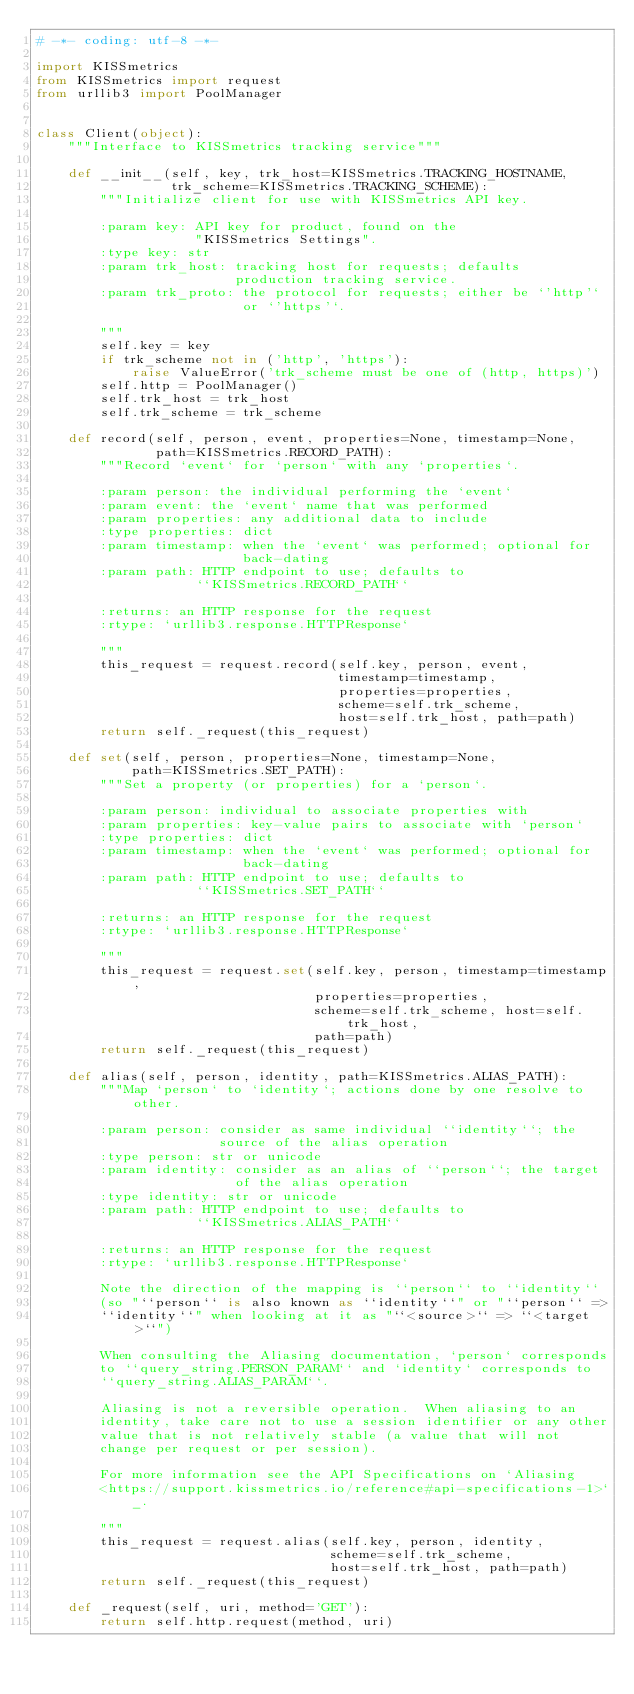Convert code to text. <code><loc_0><loc_0><loc_500><loc_500><_Python_># -*- coding: utf-8 -*-

import KISSmetrics
from KISSmetrics import request
from urllib3 import PoolManager


class Client(object):
    """Interface to KISSmetrics tracking service"""

    def __init__(self, key, trk_host=KISSmetrics.TRACKING_HOSTNAME,
                 trk_scheme=KISSmetrics.TRACKING_SCHEME):
        """Initialize client for use with KISSmetrics API key.

        :param key: API key for product, found on the
                    "KISSmetrics Settings".
        :type key: str
        :param trk_host: tracking host for requests; defaults
                         production tracking service.
        :param trk_proto: the protocol for requests; either be `'http'`
                          or `'https'`.

        """
        self.key = key
        if trk_scheme not in ('http', 'https'):
            raise ValueError('trk_scheme must be one of (http, https)')
        self.http = PoolManager()
        self.trk_host = trk_host
        self.trk_scheme = trk_scheme

    def record(self, person, event, properties=None, timestamp=None,
               path=KISSmetrics.RECORD_PATH):
        """Record `event` for `person` with any `properties`.

        :param person: the individual performing the `event`
        :param event: the `event` name that was performed
        :param properties: any additional data to include
        :type properties: dict
        :param timestamp: when the `event` was performed; optional for
                          back-dating
        :param path: HTTP endpoint to use; defaults to
                    ``KISSmetrics.RECORD_PATH``

        :returns: an HTTP response for the request
        :rtype: `urllib3.response.HTTPResponse`

        """
        this_request = request.record(self.key, person, event,
                                      timestamp=timestamp,
                                      properties=properties,
                                      scheme=self.trk_scheme,
                                      host=self.trk_host, path=path)
        return self._request(this_request)

    def set(self, person, properties=None, timestamp=None,
            path=KISSmetrics.SET_PATH):
        """Set a property (or properties) for a `person`.

        :param person: individual to associate properties with
        :param properties: key-value pairs to associate with `person`
        :type properties: dict
        :param timestamp: when the `event` was performed; optional for
                          back-dating
        :param path: HTTP endpoint to use; defaults to
                    ``KISSmetrics.SET_PATH``

        :returns: an HTTP response for the request
        :rtype: `urllib3.response.HTTPResponse`

        """
        this_request = request.set(self.key, person, timestamp=timestamp,
                                   properties=properties,
                                   scheme=self.trk_scheme, host=self.trk_host,
                                   path=path)
        return self._request(this_request)

    def alias(self, person, identity, path=KISSmetrics.ALIAS_PATH):
        """Map `person` to `identity`; actions done by one resolve to other.

        :param person: consider as same individual ``identity``; the
                       source of the alias operation
        :type person: str or unicode
        :param identity: consider as an alias of ``person``; the target
                         of the alias operation
        :type identity: str or unicode
        :param path: HTTP endpoint to use; defaults to
                    ``KISSmetrics.ALIAS_PATH``

        :returns: an HTTP response for the request
        :rtype: `urllib3.response.HTTPResponse`

        Note the direction of the mapping is ``person`` to ``identity``
        (so "``person`` is also known as ``identity``" or "``person`` =>
        ``identity``" when looking at it as "``<source>`` => ``<target>``")

        When consulting the Aliasing documentation, `person` corresponds
        to ``query_string.PERSON_PARAM`` and `identity` corresponds to
        ``query_string.ALIAS_PARAM``.

        Aliasing is not a reversible operation.  When aliasing to an
        identity, take care not to use a session identifier or any other
        value that is not relatively stable (a value that will not
        change per request or per session).

        For more information see the API Specifications on `Aliasing
        <https://support.kissmetrics.io/reference#api-specifications-1>`_.

        """
        this_request = request.alias(self.key, person, identity,
                                     scheme=self.trk_scheme,
                                     host=self.trk_host, path=path)
        return self._request(this_request)

    def _request(self, uri, method='GET'):
        return self.http.request(method, uri)
</code> 